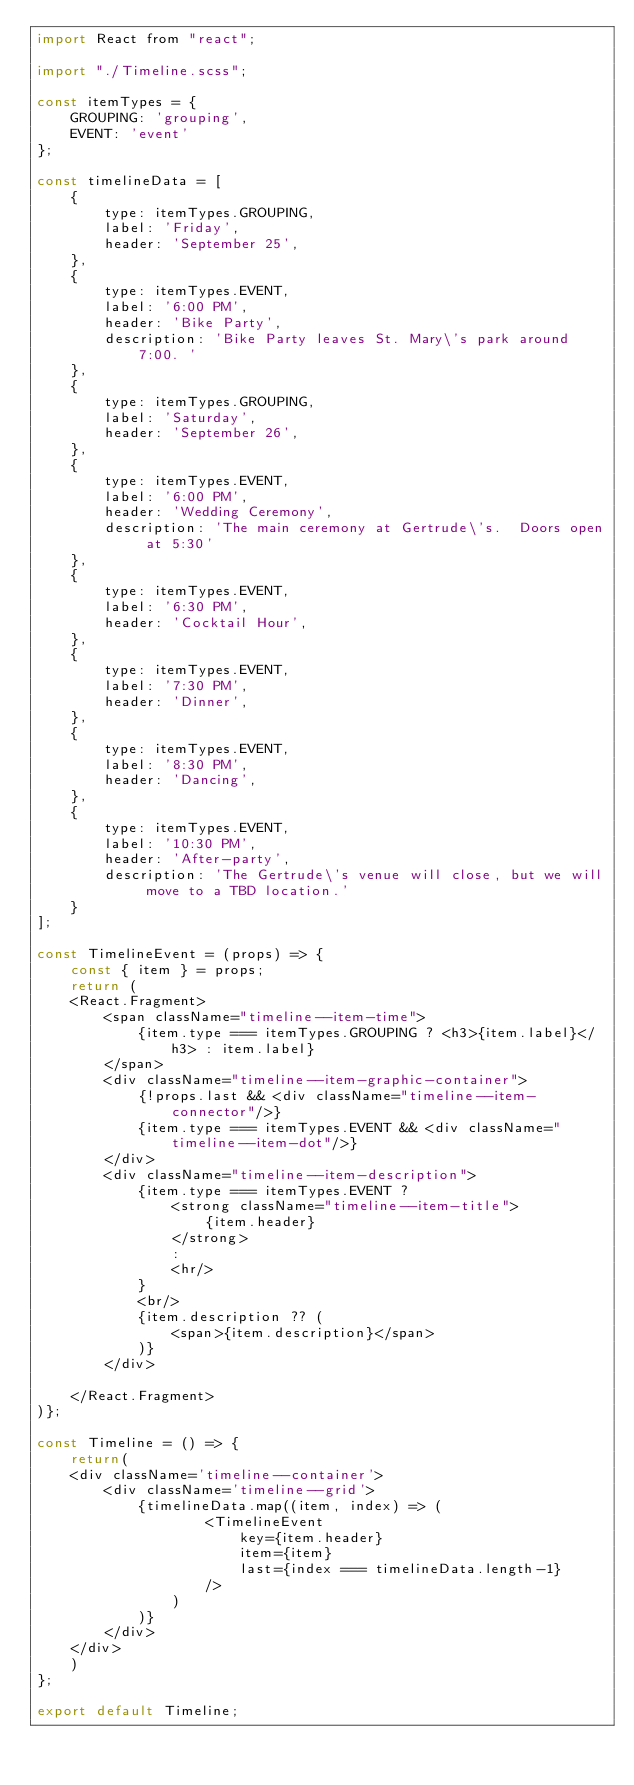<code> <loc_0><loc_0><loc_500><loc_500><_JavaScript_>import React from "react";

import "./Timeline.scss";

const itemTypes = {
    GROUPING: 'grouping',
    EVENT: 'event'
};

const timelineData = [
    {
        type: itemTypes.GROUPING,
        label: 'Friday',
        header: 'September 25',
    },
    {
        type: itemTypes.EVENT,
        label: '6:00 PM',
        header: 'Bike Party',
        description: 'Bike Party leaves St. Mary\'s park around 7:00. '
    },
    {
        type: itemTypes.GROUPING,
        label: 'Saturday',
        header: 'September 26',
    },
    {
        type: itemTypes.EVENT,
        label: '6:00 PM',
        header: 'Wedding Ceremony',
        description: 'The main ceremony at Gertrude\'s.  Doors open at 5:30'
    },
    {
        type: itemTypes.EVENT,
        label: '6:30 PM',
        header: 'Cocktail Hour',
    },
    {
        type: itemTypes.EVENT,
        label: '7:30 PM',
        header: 'Dinner',
    },
    {
        type: itemTypes.EVENT,
        label: '8:30 PM',
        header: 'Dancing',
    },
    {
        type: itemTypes.EVENT,
        label: '10:30 PM',
        header: 'After-party',
        description: 'The Gertrude\'s venue will close, but we will move to a TBD location.'
    }
];

const TimelineEvent = (props) => {
    const { item } = props;
    return (
    <React.Fragment>
        <span className="timeline--item-time">
            {item.type === itemTypes.GROUPING ? <h3>{item.label}</h3> : item.label}
        </span>
        <div className="timeline--item-graphic-container">
            {!props.last && <div className="timeline--item-connector"/>}
            {item.type === itemTypes.EVENT && <div className="timeline--item-dot"/>}
        </div>
        <div className="timeline--item-description">
            {item.type === itemTypes.EVENT ?
                <strong className="timeline--item-title">
                    {item.header}
                </strong>
                :
                <hr/>
            }
            <br/>
            {item.description ?? (
                <span>{item.description}</span>
            )}
        </div>

    </React.Fragment>
)};

const Timeline = () => {
    return(
    <div className='timeline--container'>
        <div className='timeline--grid'>
            {timelineData.map((item, index) => (
                    <TimelineEvent
                        key={item.header}
                        item={item}
                        last={index === timelineData.length-1}
                    />
                )
            )}
        </div>
    </div>
    )
};

export default Timeline;
</code> 